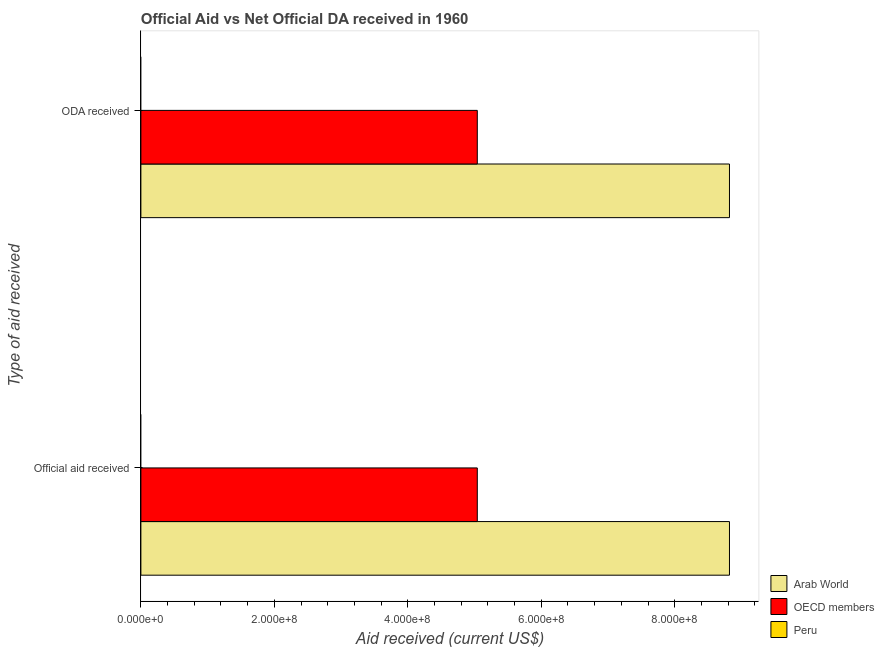How many different coloured bars are there?
Provide a succinct answer. 2. Are the number of bars on each tick of the Y-axis equal?
Ensure brevity in your answer.  Yes. How many bars are there on the 2nd tick from the top?
Provide a short and direct response. 2. What is the label of the 1st group of bars from the top?
Offer a terse response. ODA received. What is the official aid received in Arab World?
Provide a succinct answer. 8.82e+08. Across all countries, what is the maximum official aid received?
Your answer should be very brief. 8.82e+08. Across all countries, what is the minimum official aid received?
Provide a short and direct response. 0. In which country was the oda received maximum?
Offer a very short reply. Arab World. What is the total oda received in the graph?
Offer a very short reply. 1.39e+09. What is the difference between the official aid received in OECD members and that in Arab World?
Keep it short and to the point. -3.78e+08. What is the difference between the official aid received in Arab World and the oda received in OECD members?
Offer a very short reply. 3.78e+08. What is the average official aid received per country?
Provide a short and direct response. 4.62e+08. What is the difference between the oda received and official aid received in Arab World?
Give a very brief answer. 0. What is the ratio of the oda received in Arab World to that in OECD members?
Make the answer very short. 1.75. In how many countries, is the official aid received greater than the average official aid received taken over all countries?
Your answer should be very brief. 2. How many bars are there?
Provide a short and direct response. 4. Are all the bars in the graph horizontal?
Provide a succinct answer. Yes. How many countries are there in the graph?
Your answer should be very brief. 3. What is the difference between two consecutive major ticks on the X-axis?
Provide a succinct answer. 2.00e+08. How many legend labels are there?
Your response must be concise. 3. What is the title of the graph?
Give a very brief answer. Official Aid vs Net Official DA received in 1960 . What is the label or title of the X-axis?
Make the answer very short. Aid received (current US$). What is the label or title of the Y-axis?
Ensure brevity in your answer.  Type of aid received. What is the Aid received (current US$) in Arab World in Official aid received?
Offer a very short reply. 8.82e+08. What is the Aid received (current US$) of OECD members in Official aid received?
Give a very brief answer. 5.04e+08. What is the Aid received (current US$) of Arab World in ODA received?
Ensure brevity in your answer.  8.82e+08. What is the Aid received (current US$) in OECD members in ODA received?
Offer a terse response. 5.04e+08. What is the Aid received (current US$) of Peru in ODA received?
Make the answer very short. 0. Across all Type of aid received, what is the maximum Aid received (current US$) of Arab World?
Your answer should be very brief. 8.82e+08. Across all Type of aid received, what is the maximum Aid received (current US$) in OECD members?
Your response must be concise. 5.04e+08. Across all Type of aid received, what is the minimum Aid received (current US$) in Arab World?
Ensure brevity in your answer.  8.82e+08. Across all Type of aid received, what is the minimum Aid received (current US$) in OECD members?
Offer a very short reply. 5.04e+08. What is the total Aid received (current US$) of Arab World in the graph?
Your answer should be very brief. 1.76e+09. What is the total Aid received (current US$) of OECD members in the graph?
Offer a terse response. 1.01e+09. What is the total Aid received (current US$) in Peru in the graph?
Your answer should be very brief. 0. What is the difference between the Aid received (current US$) in Arab World in Official aid received and the Aid received (current US$) in OECD members in ODA received?
Ensure brevity in your answer.  3.78e+08. What is the average Aid received (current US$) in Arab World per Type of aid received?
Make the answer very short. 8.82e+08. What is the average Aid received (current US$) in OECD members per Type of aid received?
Provide a short and direct response. 5.04e+08. What is the average Aid received (current US$) of Peru per Type of aid received?
Make the answer very short. 0. What is the difference between the Aid received (current US$) of Arab World and Aid received (current US$) of OECD members in Official aid received?
Your response must be concise. 3.78e+08. What is the difference between the Aid received (current US$) in Arab World and Aid received (current US$) in OECD members in ODA received?
Your response must be concise. 3.78e+08. What is the ratio of the Aid received (current US$) in Arab World in Official aid received to that in ODA received?
Your answer should be very brief. 1. What is the difference between the highest and the second highest Aid received (current US$) in Arab World?
Give a very brief answer. 0. What is the difference between the highest and the second highest Aid received (current US$) of OECD members?
Your response must be concise. 0. What is the difference between the highest and the lowest Aid received (current US$) of OECD members?
Provide a short and direct response. 0. 